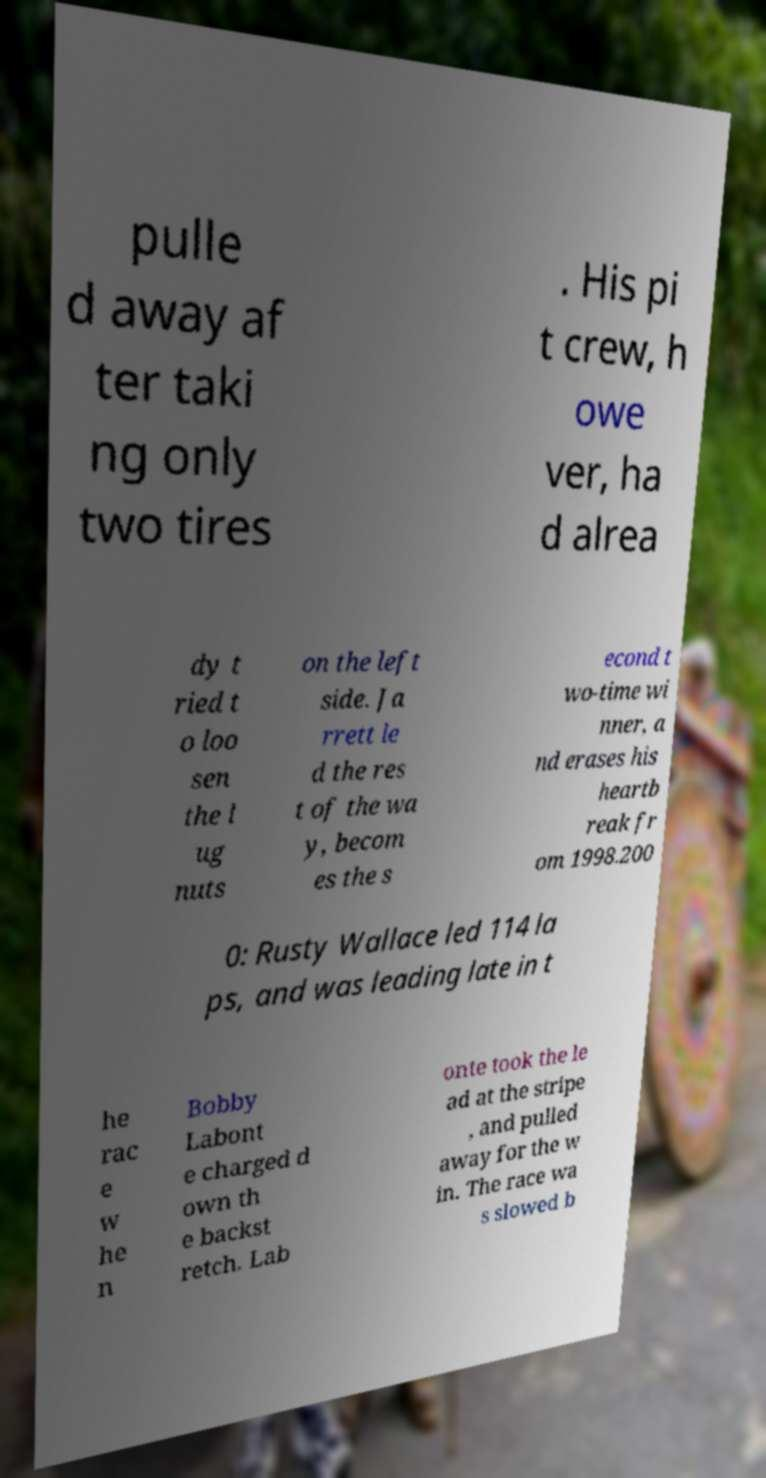What messages or text are displayed in this image? I need them in a readable, typed format. pulle d away af ter taki ng only two tires . His pi t crew, h owe ver, ha d alrea dy t ried t o loo sen the l ug nuts on the left side. Ja rrett le d the res t of the wa y, becom es the s econd t wo-time wi nner, a nd erases his heartb reak fr om 1998.200 0: Rusty Wallace led 114 la ps, and was leading late in t he rac e w he n Bobby Labont e charged d own th e backst retch. Lab onte took the le ad at the stripe , and pulled away for the w in. The race wa s slowed b 